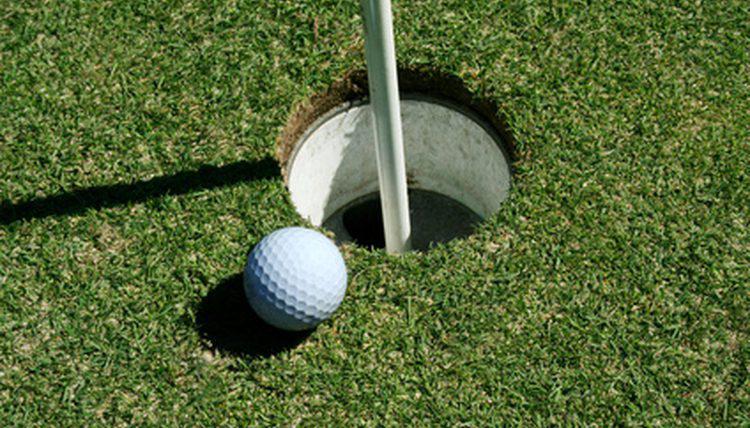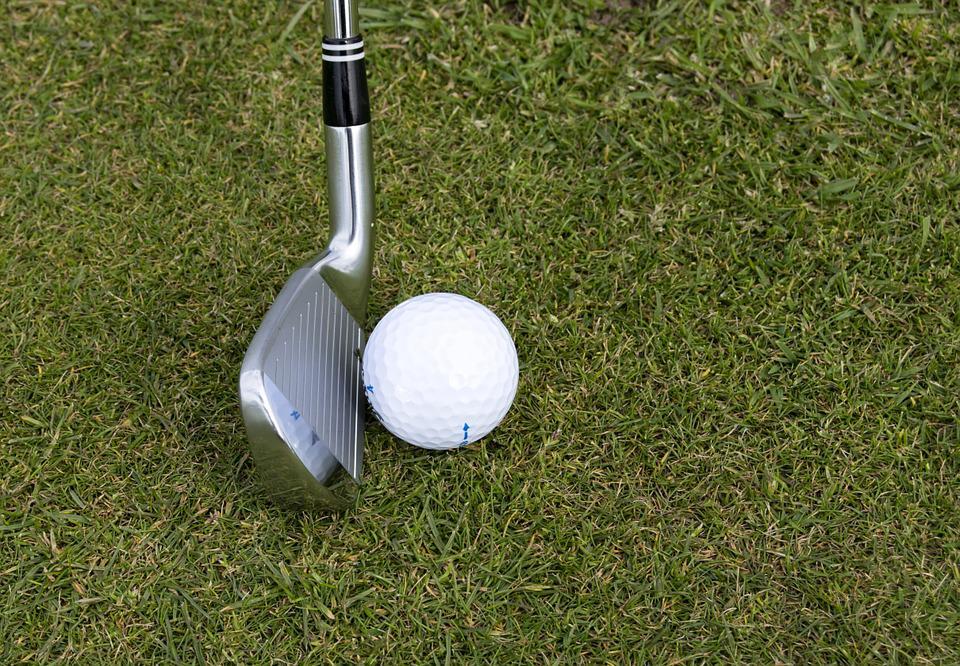The first image is the image on the left, the second image is the image on the right. Examine the images to the left and right. Is the description "The golf ball in the left image is on a tee." accurate? Answer yes or no. No. 